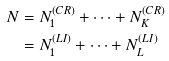<formula> <loc_0><loc_0><loc_500><loc_500>N & = N _ { 1 } ^ { ( C R ) } + \dots + N _ { K } ^ { ( C R ) } \\ & = N _ { 1 } ^ { ( L I ) } + \dots + N _ { L } ^ { ( L I ) }</formula> 